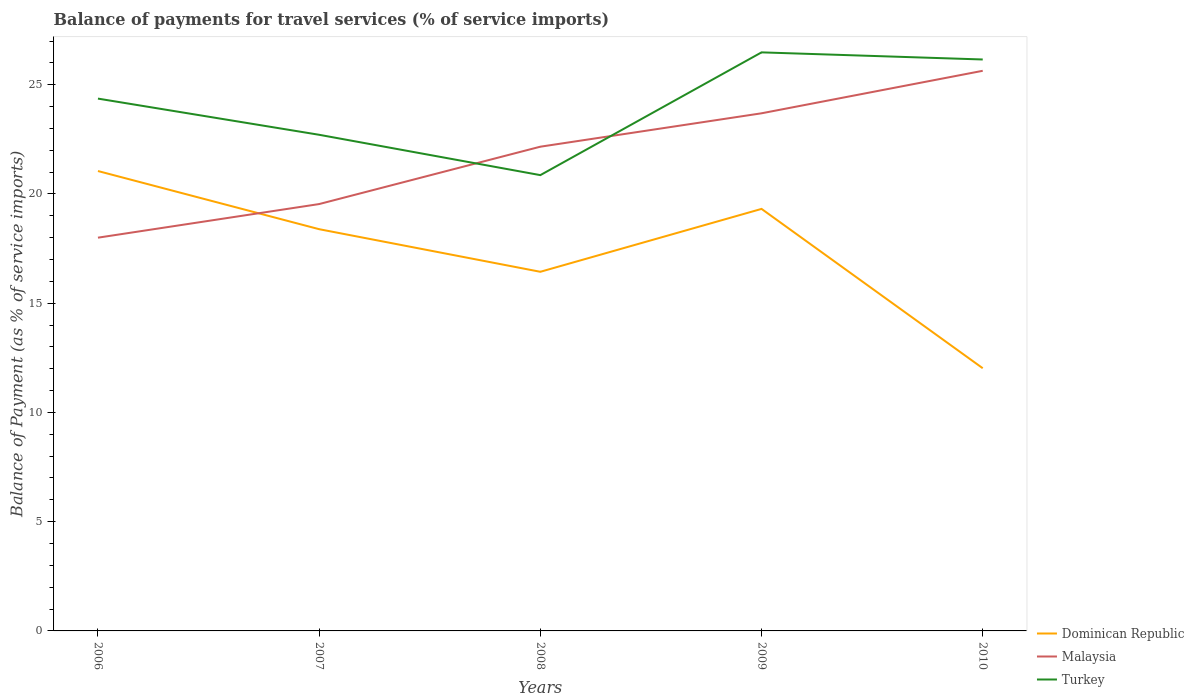Does the line corresponding to Dominican Republic intersect with the line corresponding to Malaysia?
Keep it short and to the point. Yes. Is the number of lines equal to the number of legend labels?
Give a very brief answer. Yes. Across all years, what is the maximum balance of payments for travel services in Dominican Republic?
Offer a terse response. 12.02. In which year was the balance of payments for travel services in Turkey maximum?
Give a very brief answer. 2008. What is the total balance of payments for travel services in Turkey in the graph?
Offer a terse response. -3.45. What is the difference between the highest and the second highest balance of payments for travel services in Malaysia?
Make the answer very short. 7.64. What is the difference between the highest and the lowest balance of payments for travel services in Dominican Republic?
Provide a short and direct response. 3. How many lines are there?
Ensure brevity in your answer.  3. What is the difference between two consecutive major ticks on the Y-axis?
Make the answer very short. 5. Does the graph contain any zero values?
Give a very brief answer. No. How many legend labels are there?
Provide a succinct answer. 3. What is the title of the graph?
Offer a terse response. Balance of payments for travel services (% of service imports). Does "OECD members" appear as one of the legend labels in the graph?
Keep it short and to the point. No. What is the label or title of the Y-axis?
Give a very brief answer. Balance of Payment (as % of service imports). What is the Balance of Payment (as % of service imports) of Dominican Republic in 2006?
Your response must be concise. 21.05. What is the Balance of Payment (as % of service imports) of Malaysia in 2006?
Offer a terse response. 18. What is the Balance of Payment (as % of service imports) in Turkey in 2006?
Your answer should be very brief. 24.36. What is the Balance of Payment (as % of service imports) of Dominican Republic in 2007?
Your answer should be compact. 18.39. What is the Balance of Payment (as % of service imports) of Malaysia in 2007?
Make the answer very short. 19.54. What is the Balance of Payment (as % of service imports) of Turkey in 2007?
Provide a succinct answer. 22.71. What is the Balance of Payment (as % of service imports) in Dominican Republic in 2008?
Your answer should be compact. 16.44. What is the Balance of Payment (as % of service imports) of Malaysia in 2008?
Provide a succinct answer. 22.16. What is the Balance of Payment (as % of service imports) in Turkey in 2008?
Keep it short and to the point. 20.86. What is the Balance of Payment (as % of service imports) of Dominican Republic in 2009?
Keep it short and to the point. 19.32. What is the Balance of Payment (as % of service imports) in Malaysia in 2009?
Keep it short and to the point. 23.69. What is the Balance of Payment (as % of service imports) in Turkey in 2009?
Keep it short and to the point. 26.48. What is the Balance of Payment (as % of service imports) of Dominican Republic in 2010?
Offer a terse response. 12.02. What is the Balance of Payment (as % of service imports) of Malaysia in 2010?
Ensure brevity in your answer.  25.64. What is the Balance of Payment (as % of service imports) of Turkey in 2010?
Provide a short and direct response. 26.15. Across all years, what is the maximum Balance of Payment (as % of service imports) of Dominican Republic?
Keep it short and to the point. 21.05. Across all years, what is the maximum Balance of Payment (as % of service imports) of Malaysia?
Offer a very short reply. 25.64. Across all years, what is the maximum Balance of Payment (as % of service imports) of Turkey?
Make the answer very short. 26.48. Across all years, what is the minimum Balance of Payment (as % of service imports) of Dominican Republic?
Keep it short and to the point. 12.02. Across all years, what is the minimum Balance of Payment (as % of service imports) of Malaysia?
Ensure brevity in your answer.  18. Across all years, what is the minimum Balance of Payment (as % of service imports) in Turkey?
Your response must be concise. 20.86. What is the total Balance of Payment (as % of service imports) in Dominican Republic in the graph?
Your response must be concise. 87.21. What is the total Balance of Payment (as % of service imports) of Malaysia in the graph?
Provide a short and direct response. 109.03. What is the total Balance of Payment (as % of service imports) in Turkey in the graph?
Your answer should be very brief. 120.57. What is the difference between the Balance of Payment (as % of service imports) of Dominican Republic in 2006 and that in 2007?
Provide a short and direct response. 2.66. What is the difference between the Balance of Payment (as % of service imports) in Malaysia in 2006 and that in 2007?
Offer a terse response. -1.54. What is the difference between the Balance of Payment (as % of service imports) in Turkey in 2006 and that in 2007?
Your answer should be compact. 1.66. What is the difference between the Balance of Payment (as % of service imports) in Dominican Republic in 2006 and that in 2008?
Your answer should be very brief. 4.61. What is the difference between the Balance of Payment (as % of service imports) in Malaysia in 2006 and that in 2008?
Ensure brevity in your answer.  -4.16. What is the difference between the Balance of Payment (as % of service imports) in Turkey in 2006 and that in 2008?
Make the answer very short. 3.5. What is the difference between the Balance of Payment (as % of service imports) in Dominican Republic in 2006 and that in 2009?
Make the answer very short. 1.73. What is the difference between the Balance of Payment (as % of service imports) in Malaysia in 2006 and that in 2009?
Ensure brevity in your answer.  -5.69. What is the difference between the Balance of Payment (as % of service imports) in Turkey in 2006 and that in 2009?
Your answer should be compact. -2.12. What is the difference between the Balance of Payment (as % of service imports) of Dominican Republic in 2006 and that in 2010?
Give a very brief answer. 9.03. What is the difference between the Balance of Payment (as % of service imports) in Malaysia in 2006 and that in 2010?
Offer a terse response. -7.64. What is the difference between the Balance of Payment (as % of service imports) in Turkey in 2006 and that in 2010?
Make the answer very short. -1.79. What is the difference between the Balance of Payment (as % of service imports) of Dominican Republic in 2007 and that in 2008?
Your response must be concise. 1.95. What is the difference between the Balance of Payment (as % of service imports) in Malaysia in 2007 and that in 2008?
Keep it short and to the point. -2.63. What is the difference between the Balance of Payment (as % of service imports) in Turkey in 2007 and that in 2008?
Make the answer very short. 1.85. What is the difference between the Balance of Payment (as % of service imports) in Dominican Republic in 2007 and that in 2009?
Your answer should be very brief. -0.93. What is the difference between the Balance of Payment (as % of service imports) of Malaysia in 2007 and that in 2009?
Keep it short and to the point. -4.15. What is the difference between the Balance of Payment (as % of service imports) in Turkey in 2007 and that in 2009?
Offer a very short reply. -3.77. What is the difference between the Balance of Payment (as % of service imports) of Dominican Republic in 2007 and that in 2010?
Your response must be concise. 6.36. What is the difference between the Balance of Payment (as % of service imports) of Malaysia in 2007 and that in 2010?
Your answer should be very brief. -6.1. What is the difference between the Balance of Payment (as % of service imports) of Turkey in 2007 and that in 2010?
Provide a short and direct response. -3.45. What is the difference between the Balance of Payment (as % of service imports) in Dominican Republic in 2008 and that in 2009?
Provide a short and direct response. -2.88. What is the difference between the Balance of Payment (as % of service imports) of Malaysia in 2008 and that in 2009?
Your answer should be compact. -1.53. What is the difference between the Balance of Payment (as % of service imports) of Turkey in 2008 and that in 2009?
Give a very brief answer. -5.62. What is the difference between the Balance of Payment (as % of service imports) in Dominican Republic in 2008 and that in 2010?
Keep it short and to the point. 4.41. What is the difference between the Balance of Payment (as % of service imports) of Malaysia in 2008 and that in 2010?
Provide a short and direct response. -3.47. What is the difference between the Balance of Payment (as % of service imports) of Turkey in 2008 and that in 2010?
Give a very brief answer. -5.29. What is the difference between the Balance of Payment (as % of service imports) of Dominican Republic in 2009 and that in 2010?
Provide a short and direct response. 7.29. What is the difference between the Balance of Payment (as % of service imports) in Malaysia in 2009 and that in 2010?
Make the answer very short. -1.95. What is the difference between the Balance of Payment (as % of service imports) of Turkey in 2009 and that in 2010?
Provide a succinct answer. 0.33. What is the difference between the Balance of Payment (as % of service imports) in Dominican Republic in 2006 and the Balance of Payment (as % of service imports) in Malaysia in 2007?
Provide a succinct answer. 1.51. What is the difference between the Balance of Payment (as % of service imports) of Dominican Republic in 2006 and the Balance of Payment (as % of service imports) of Turkey in 2007?
Offer a very short reply. -1.66. What is the difference between the Balance of Payment (as % of service imports) of Malaysia in 2006 and the Balance of Payment (as % of service imports) of Turkey in 2007?
Offer a terse response. -4.71. What is the difference between the Balance of Payment (as % of service imports) in Dominican Republic in 2006 and the Balance of Payment (as % of service imports) in Malaysia in 2008?
Your answer should be compact. -1.11. What is the difference between the Balance of Payment (as % of service imports) of Dominican Republic in 2006 and the Balance of Payment (as % of service imports) of Turkey in 2008?
Make the answer very short. 0.19. What is the difference between the Balance of Payment (as % of service imports) in Malaysia in 2006 and the Balance of Payment (as % of service imports) in Turkey in 2008?
Provide a succinct answer. -2.86. What is the difference between the Balance of Payment (as % of service imports) in Dominican Republic in 2006 and the Balance of Payment (as % of service imports) in Malaysia in 2009?
Offer a very short reply. -2.64. What is the difference between the Balance of Payment (as % of service imports) in Dominican Republic in 2006 and the Balance of Payment (as % of service imports) in Turkey in 2009?
Keep it short and to the point. -5.43. What is the difference between the Balance of Payment (as % of service imports) in Malaysia in 2006 and the Balance of Payment (as % of service imports) in Turkey in 2009?
Provide a succinct answer. -8.48. What is the difference between the Balance of Payment (as % of service imports) in Dominican Republic in 2006 and the Balance of Payment (as % of service imports) in Malaysia in 2010?
Your answer should be very brief. -4.59. What is the difference between the Balance of Payment (as % of service imports) in Dominican Republic in 2006 and the Balance of Payment (as % of service imports) in Turkey in 2010?
Your response must be concise. -5.11. What is the difference between the Balance of Payment (as % of service imports) of Malaysia in 2006 and the Balance of Payment (as % of service imports) of Turkey in 2010?
Your answer should be compact. -8.16. What is the difference between the Balance of Payment (as % of service imports) of Dominican Republic in 2007 and the Balance of Payment (as % of service imports) of Malaysia in 2008?
Provide a short and direct response. -3.78. What is the difference between the Balance of Payment (as % of service imports) of Dominican Republic in 2007 and the Balance of Payment (as % of service imports) of Turkey in 2008?
Offer a very short reply. -2.47. What is the difference between the Balance of Payment (as % of service imports) of Malaysia in 2007 and the Balance of Payment (as % of service imports) of Turkey in 2008?
Provide a short and direct response. -1.32. What is the difference between the Balance of Payment (as % of service imports) in Dominican Republic in 2007 and the Balance of Payment (as % of service imports) in Malaysia in 2009?
Make the answer very short. -5.3. What is the difference between the Balance of Payment (as % of service imports) of Dominican Republic in 2007 and the Balance of Payment (as % of service imports) of Turkey in 2009?
Ensure brevity in your answer.  -8.09. What is the difference between the Balance of Payment (as % of service imports) in Malaysia in 2007 and the Balance of Payment (as % of service imports) in Turkey in 2009?
Give a very brief answer. -6.94. What is the difference between the Balance of Payment (as % of service imports) of Dominican Republic in 2007 and the Balance of Payment (as % of service imports) of Malaysia in 2010?
Make the answer very short. -7.25. What is the difference between the Balance of Payment (as % of service imports) in Dominican Republic in 2007 and the Balance of Payment (as % of service imports) in Turkey in 2010?
Make the answer very short. -7.77. What is the difference between the Balance of Payment (as % of service imports) of Malaysia in 2007 and the Balance of Payment (as % of service imports) of Turkey in 2010?
Make the answer very short. -6.62. What is the difference between the Balance of Payment (as % of service imports) of Dominican Republic in 2008 and the Balance of Payment (as % of service imports) of Malaysia in 2009?
Provide a succinct answer. -7.25. What is the difference between the Balance of Payment (as % of service imports) of Dominican Republic in 2008 and the Balance of Payment (as % of service imports) of Turkey in 2009?
Provide a short and direct response. -10.04. What is the difference between the Balance of Payment (as % of service imports) of Malaysia in 2008 and the Balance of Payment (as % of service imports) of Turkey in 2009?
Offer a terse response. -4.32. What is the difference between the Balance of Payment (as % of service imports) of Dominican Republic in 2008 and the Balance of Payment (as % of service imports) of Malaysia in 2010?
Offer a terse response. -9.2. What is the difference between the Balance of Payment (as % of service imports) in Dominican Republic in 2008 and the Balance of Payment (as % of service imports) in Turkey in 2010?
Offer a terse response. -9.72. What is the difference between the Balance of Payment (as % of service imports) in Malaysia in 2008 and the Balance of Payment (as % of service imports) in Turkey in 2010?
Ensure brevity in your answer.  -3.99. What is the difference between the Balance of Payment (as % of service imports) of Dominican Republic in 2009 and the Balance of Payment (as % of service imports) of Malaysia in 2010?
Offer a very short reply. -6.32. What is the difference between the Balance of Payment (as % of service imports) of Dominican Republic in 2009 and the Balance of Payment (as % of service imports) of Turkey in 2010?
Offer a very short reply. -6.84. What is the difference between the Balance of Payment (as % of service imports) in Malaysia in 2009 and the Balance of Payment (as % of service imports) in Turkey in 2010?
Keep it short and to the point. -2.46. What is the average Balance of Payment (as % of service imports) of Dominican Republic per year?
Your answer should be compact. 17.44. What is the average Balance of Payment (as % of service imports) of Malaysia per year?
Provide a succinct answer. 21.81. What is the average Balance of Payment (as % of service imports) of Turkey per year?
Ensure brevity in your answer.  24.11. In the year 2006, what is the difference between the Balance of Payment (as % of service imports) in Dominican Republic and Balance of Payment (as % of service imports) in Malaysia?
Your answer should be very brief. 3.05. In the year 2006, what is the difference between the Balance of Payment (as % of service imports) in Dominican Republic and Balance of Payment (as % of service imports) in Turkey?
Your answer should be compact. -3.31. In the year 2006, what is the difference between the Balance of Payment (as % of service imports) of Malaysia and Balance of Payment (as % of service imports) of Turkey?
Provide a succinct answer. -6.37. In the year 2007, what is the difference between the Balance of Payment (as % of service imports) of Dominican Republic and Balance of Payment (as % of service imports) of Malaysia?
Provide a succinct answer. -1.15. In the year 2007, what is the difference between the Balance of Payment (as % of service imports) in Dominican Republic and Balance of Payment (as % of service imports) in Turkey?
Offer a terse response. -4.32. In the year 2007, what is the difference between the Balance of Payment (as % of service imports) of Malaysia and Balance of Payment (as % of service imports) of Turkey?
Provide a short and direct response. -3.17. In the year 2008, what is the difference between the Balance of Payment (as % of service imports) of Dominican Republic and Balance of Payment (as % of service imports) of Malaysia?
Your answer should be compact. -5.73. In the year 2008, what is the difference between the Balance of Payment (as % of service imports) of Dominican Republic and Balance of Payment (as % of service imports) of Turkey?
Make the answer very short. -4.42. In the year 2008, what is the difference between the Balance of Payment (as % of service imports) in Malaysia and Balance of Payment (as % of service imports) in Turkey?
Your answer should be very brief. 1.3. In the year 2009, what is the difference between the Balance of Payment (as % of service imports) of Dominican Republic and Balance of Payment (as % of service imports) of Malaysia?
Provide a short and direct response. -4.38. In the year 2009, what is the difference between the Balance of Payment (as % of service imports) of Dominican Republic and Balance of Payment (as % of service imports) of Turkey?
Provide a short and direct response. -7.16. In the year 2009, what is the difference between the Balance of Payment (as % of service imports) of Malaysia and Balance of Payment (as % of service imports) of Turkey?
Provide a succinct answer. -2.79. In the year 2010, what is the difference between the Balance of Payment (as % of service imports) in Dominican Republic and Balance of Payment (as % of service imports) in Malaysia?
Your answer should be very brief. -13.61. In the year 2010, what is the difference between the Balance of Payment (as % of service imports) of Dominican Republic and Balance of Payment (as % of service imports) of Turkey?
Ensure brevity in your answer.  -14.13. In the year 2010, what is the difference between the Balance of Payment (as % of service imports) of Malaysia and Balance of Payment (as % of service imports) of Turkey?
Your response must be concise. -0.52. What is the ratio of the Balance of Payment (as % of service imports) in Dominican Republic in 2006 to that in 2007?
Provide a succinct answer. 1.14. What is the ratio of the Balance of Payment (as % of service imports) of Malaysia in 2006 to that in 2007?
Your response must be concise. 0.92. What is the ratio of the Balance of Payment (as % of service imports) of Turkey in 2006 to that in 2007?
Provide a short and direct response. 1.07. What is the ratio of the Balance of Payment (as % of service imports) of Dominican Republic in 2006 to that in 2008?
Offer a terse response. 1.28. What is the ratio of the Balance of Payment (as % of service imports) of Malaysia in 2006 to that in 2008?
Provide a short and direct response. 0.81. What is the ratio of the Balance of Payment (as % of service imports) of Turkey in 2006 to that in 2008?
Give a very brief answer. 1.17. What is the ratio of the Balance of Payment (as % of service imports) in Dominican Republic in 2006 to that in 2009?
Offer a terse response. 1.09. What is the ratio of the Balance of Payment (as % of service imports) in Malaysia in 2006 to that in 2009?
Your answer should be very brief. 0.76. What is the ratio of the Balance of Payment (as % of service imports) in Turkey in 2006 to that in 2009?
Offer a terse response. 0.92. What is the ratio of the Balance of Payment (as % of service imports) of Dominican Republic in 2006 to that in 2010?
Your answer should be compact. 1.75. What is the ratio of the Balance of Payment (as % of service imports) of Malaysia in 2006 to that in 2010?
Your response must be concise. 0.7. What is the ratio of the Balance of Payment (as % of service imports) in Turkey in 2006 to that in 2010?
Make the answer very short. 0.93. What is the ratio of the Balance of Payment (as % of service imports) in Dominican Republic in 2007 to that in 2008?
Your response must be concise. 1.12. What is the ratio of the Balance of Payment (as % of service imports) of Malaysia in 2007 to that in 2008?
Provide a succinct answer. 0.88. What is the ratio of the Balance of Payment (as % of service imports) of Turkey in 2007 to that in 2008?
Offer a terse response. 1.09. What is the ratio of the Balance of Payment (as % of service imports) in Dominican Republic in 2007 to that in 2009?
Provide a succinct answer. 0.95. What is the ratio of the Balance of Payment (as % of service imports) in Malaysia in 2007 to that in 2009?
Offer a very short reply. 0.82. What is the ratio of the Balance of Payment (as % of service imports) of Turkey in 2007 to that in 2009?
Your answer should be very brief. 0.86. What is the ratio of the Balance of Payment (as % of service imports) in Dominican Republic in 2007 to that in 2010?
Your answer should be compact. 1.53. What is the ratio of the Balance of Payment (as % of service imports) of Malaysia in 2007 to that in 2010?
Offer a terse response. 0.76. What is the ratio of the Balance of Payment (as % of service imports) in Turkey in 2007 to that in 2010?
Provide a short and direct response. 0.87. What is the ratio of the Balance of Payment (as % of service imports) in Dominican Republic in 2008 to that in 2009?
Offer a very short reply. 0.85. What is the ratio of the Balance of Payment (as % of service imports) of Malaysia in 2008 to that in 2009?
Your answer should be compact. 0.94. What is the ratio of the Balance of Payment (as % of service imports) of Turkey in 2008 to that in 2009?
Offer a terse response. 0.79. What is the ratio of the Balance of Payment (as % of service imports) of Dominican Republic in 2008 to that in 2010?
Provide a succinct answer. 1.37. What is the ratio of the Balance of Payment (as % of service imports) of Malaysia in 2008 to that in 2010?
Your response must be concise. 0.86. What is the ratio of the Balance of Payment (as % of service imports) of Turkey in 2008 to that in 2010?
Offer a terse response. 0.8. What is the ratio of the Balance of Payment (as % of service imports) in Dominican Republic in 2009 to that in 2010?
Ensure brevity in your answer.  1.61. What is the ratio of the Balance of Payment (as % of service imports) in Malaysia in 2009 to that in 2010?
Your response must be concise. 0.92. What is the ratio of the Balance of Payment (as % of service imports) of Turkey in 2009 to that in 2010?
Your response must be concise. 1.01. What is the difference between the highest and the second highest Balance of Payment (as % of service imports) in Dominican Republic?
Provide a short and direct response. 1.73. What is the difference between the highest and the second highest Balance of Payment (as % of service imports) of Malaysia?
Offer a very short reply. 1.95. What is the difference between the highest and the second highest Balance of Payment (as % of service imports) in Turkey?
Give a very brief answer. 0.33. What is the difference between the highest and the lowest Balance of Payment (as % of service imports) of Dominican Republic?
Provide a succinct answer. 9.03. What is the difference between the highest and the lowest Balance of Payment (as % of service imports) in Malaysia?
Ensure brevity in your answer.  7.64. What is the difference between the highest and the lowest Balance of Payment (as % of service imports) of Turkey?
Keep it short and to the point. 5.62. 